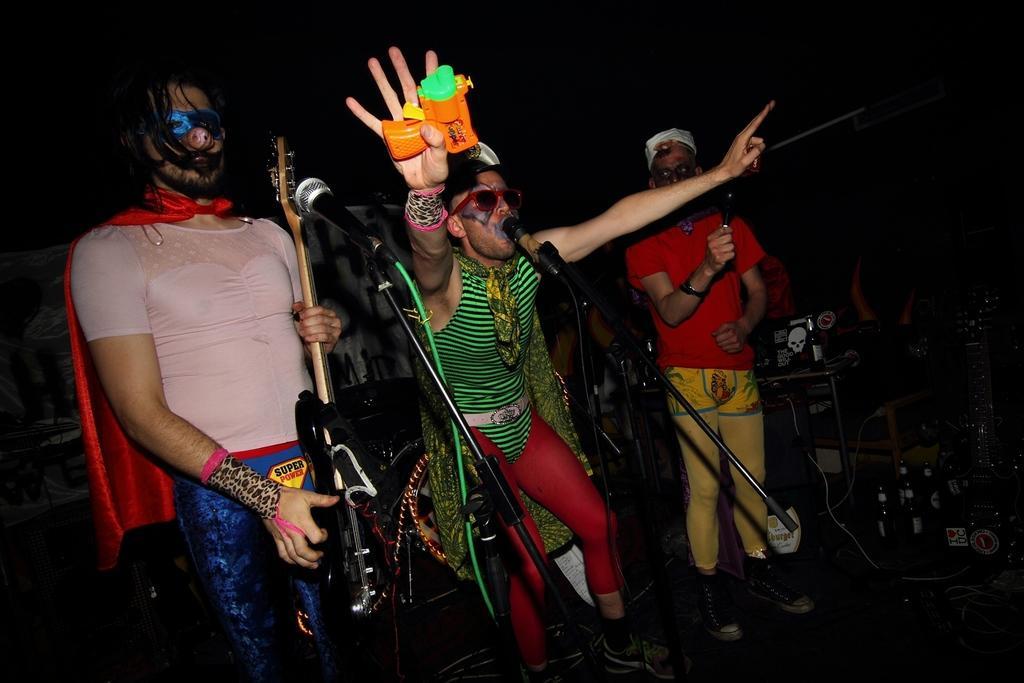Can you describe this image briefly? In a club, there is some event going on and there are three people standing on the stage and they are singing songs and playing music, beside the people there are alcohol bottles and some other equipment. The first person is playing the guitar and the remaining two are singing songs. 